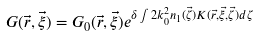<formula> <loc_0><loc_0><loc_500><loc_500>G ( \vec { r } , \vec { \xi } ) = G _ { 0 } ( \vec { r } , \vec { \xi } ) e ^ { \delta \int 2 k _ { 0 } ^ { 2 } n _ { 1 } ( \vec { \zeta } ) K ( \vec { r } , \vec { \xi } , \vec { \zeta } ) d \zeta }</formula> 